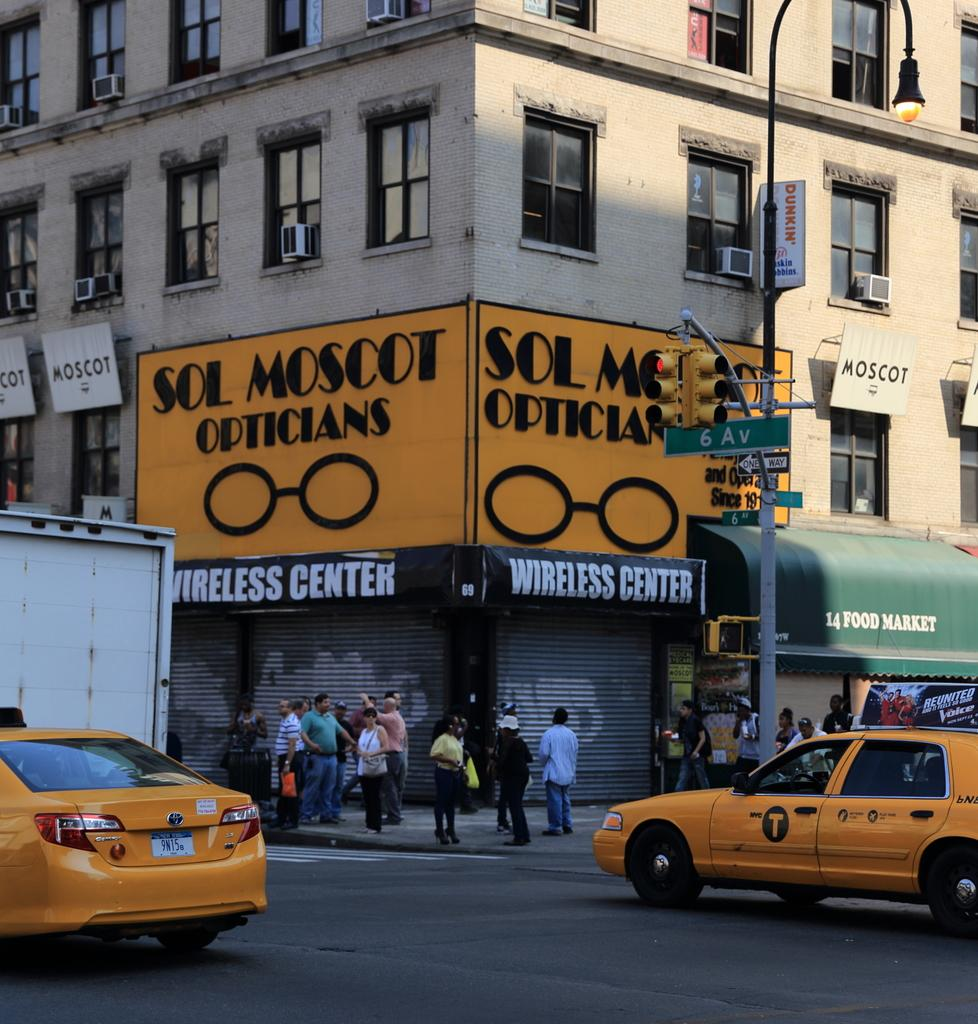<image>
Offer a succinct explanation of the picture presented. The corner shop is called Sol Moscot Opticians. 